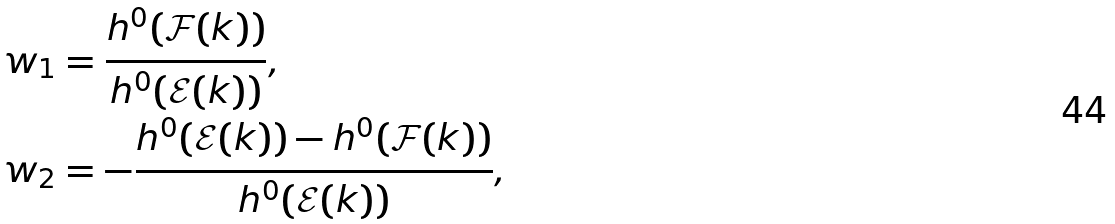Convert formula to latex. <formula><loc_0><loc_0><loc_500><loc_500>w _ { 1 } & = \frac { h ^ { 0 } ( \mathcal { F } ( k ) ) } { h ^ { 0 } ( \mathcal { E } ( k ) ) } , \\ w _ { 2 } & = - \frac { h ^ { 0 } ( \mathcal { E } ( k ) ) - h ^ { 0 } ( \mathcal { F } ( k ) ) } { h ^ { 0 } ( \mathcal { E } ( k ) ) } ,</formula> 